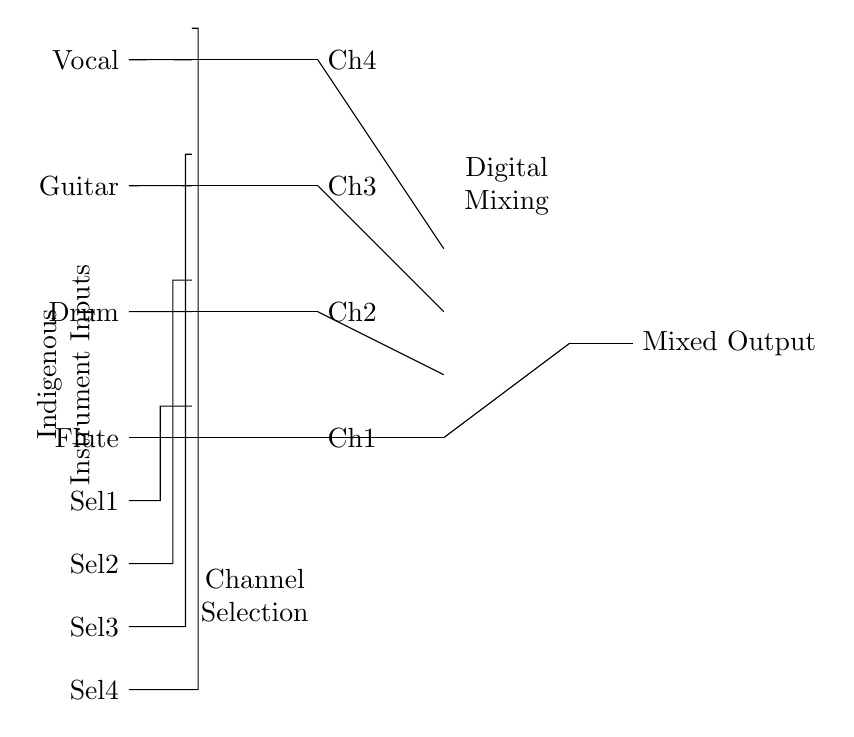What types of instruments are inputs to this mixer? The inputs to the mixer are labeled as Flute, Drum, Guitar, and Vocal, which are indigenous instruments. Thus, the circuit accommodates these types.
Answer: Flute, Drum, Guitar, Vocal How many AND gates are in the circuit? The circuit diagram shows four AND gates, one for each instrument input channel. Each gate is connected to a corresponding instrument for selection.
Answer: Four What channel corresponds to the Drum input? The Drum input connects to Channel 2 as indicated in the circuit, where the AND gate for the Drum input is labeled as Ch2.
Answer: Ch2 What is the function of the OR gate in this circuit? The OR gate at the end of the channel connections is used to mix the outputs from all the AND gates, combining the selected instrument sounds into one mixed output.
Answer: Mixing Which selector is meant for Vocal input? The Vocal input has the selector labeled Sel4, which routes the signal to the AND gate for processing before mixing.
Answer: Sel4 How many inputs can the OR gate handle? The OR gate in the circuit is designed to handle four inputs, as stated in the diagram with the notation for number inputs.
Answer: Four Which logic gates are used in this circuit? The circuit employs AND gates for input selection and an OR gate for output mixing, illustrating basic logic gate functions in audio mixing.
Answer: AND, OR 